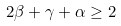Convert formula to latex. <formula><loc_0><loc_0><loc_500><loc_500>2 \beta + \gamma + \alpha \geq 2</formula> 